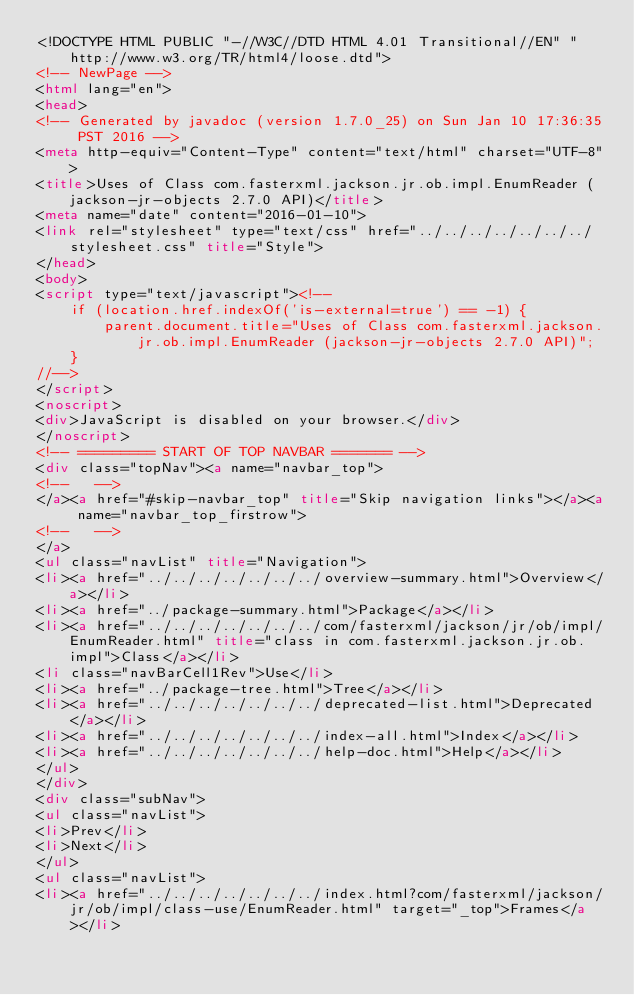Convert code to text. <code><loc_0><loc_0><loc_500><loc_500><_HTML_><!DOCTYPE HTML PUBLIC "-//W3C//DTD HTML 4.01 Transitional//EN" "http://www.w3.org/TR/html4/loose.dtd">
<!-- NewPage -->
<html lang="en">
<head>
<!-- Generated by javadoc (version 1.7.0_25) on Sun Jan 10 17:36:35 PST 2016 -->
<meta http-equiv="Content-Type" content="text/html" charset="UTF-8">
<title>Uses of Class com.fasterxml.jackson.jr.ob.impl.EnumReader (jackson-jr-objects 2.7.0 API)</title>
<meta name="date" content="2016-01-10">
<link rel="stylesheet" type="text/css" href="../../../../../../../stylesheet.css" title="Style">
</head>
<body>
<script type="text/javascript"><!--
    if (location.href.indexOf('is-external=true') == -1) {
        parent.document.title="Uses of Class com.fasterxml.jackson.jr.ob.impl.EnumReader (jackson-jr-objects 2.7.0 API)";
    }
//-->
</script>
<noscript>
<div>JavaScript is disabled on your browser.</div>
</noscript>
<!-- ========= START OF TOP NAVBAR ======= -->
<div class="topNav"><a name="navbar_top">
<!--   -->
</a><a href="#skip-navbar_top" title="Skip navigation links"></a><a name="navbar_top_firstrow">
<!--   -->
</a>
<ul class="navList" title="Navigation">
<li><a href="../../../../../../../overview-summary.html">Overview</a></li>
<li><a href="../package-summary.html">Package</a></li>
<li><a href="../../../../../../../com/fasterxml/jackson/jr/ob/impl/EnumReader.html" title="class in com.fasterxml.jackson.jr.ob.impl">Class</a></li>
<li class="navBarCell1Rev">Use</li>
<li><a href="../package-tree.html">Tree</a></li>
<li><a href="../../../../../../../deprecated-list.html">Deprecated</a></li>
<li><a href="../../../../../../../index-all.html">Index</a></li>
<li><a href="../../../../../../../help-doc.html">Help</a></li>
</ul>
</div>
<div class="subNav">
<ul class="navList">
<li>Prev</li>
<li>Next</li>
</ul>
<ul class="navList">
<li><a href="../../../../../../../index.html?com/fasterxml/jackson/jr/ob/impl/class-use/EnumReader.html" target="_top">Frames</a></li></code> 